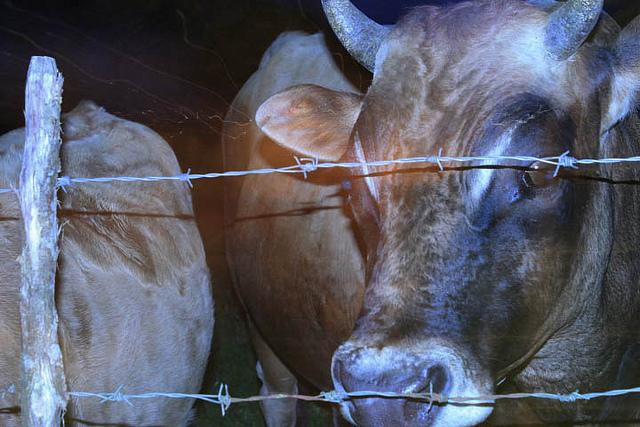What is the fence made of?
Quick response, please. Barbed wire. Would the fence hurt?
Answer briefly. Yes. If the cow moved 4 inches to right would it step on the other cows foot?
Be succinct. No. 